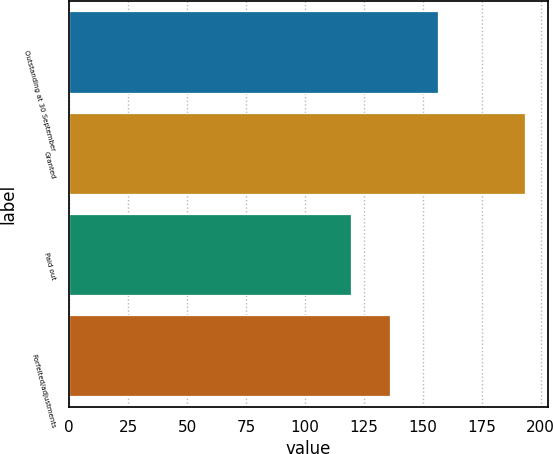<chart> <loc_0><loc_0><loc_500><loc_500><bar_chart><fcel>Outstanding at 30 September<fcel>Granted<fcel>Paid out<fcel>Forfeited/adjustments<nl><fcel>156.31<fcel>193.29<fcel>119.59<fcel>136.11<nl></chart> 